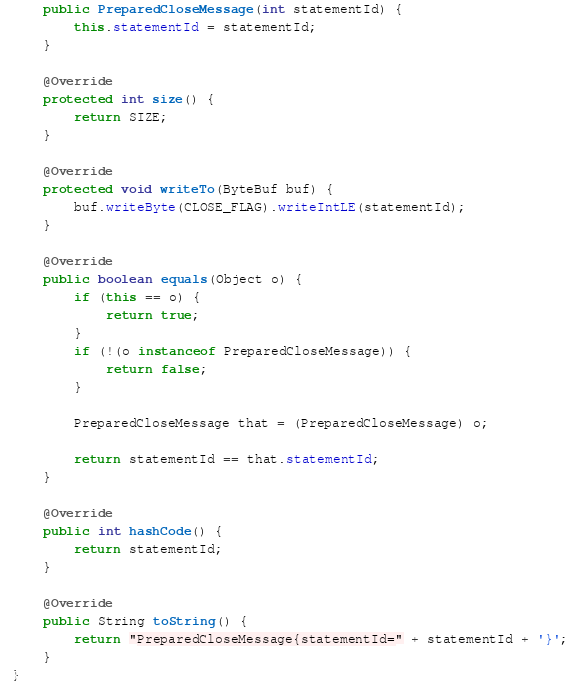<code> <loc_0><loc_0><loc_500><loc_500><_Java_>    public PreparedCloseMessage(int statementId) {
        this.statementId = statementId;
    }

    @Override
    protected int size() {
        return SIZE;
    }

    @Override
    protected void writeTo(ByteBuf buf) {
        buf.writeByte(CLOSE_FLAG).writeIntLE(statementId);
    }

    @Override
    public boolean equals(Object o) {
        if (this == o) {
            return true;
        }
        if (!(o instanceof PreparedCloseMessage)) {
            return false;
        }

        PreparedCloseMessage that = (PreparedCloseMessage) o;

        return statementId == that.statementId;
    }

    @Override
    public int hashCode() {
        return statementId;
    }

    @Override
    public String toString() {
        return "PreparedCloseMessage{statementId=" + statementId + '}';
    }
}
</code> 